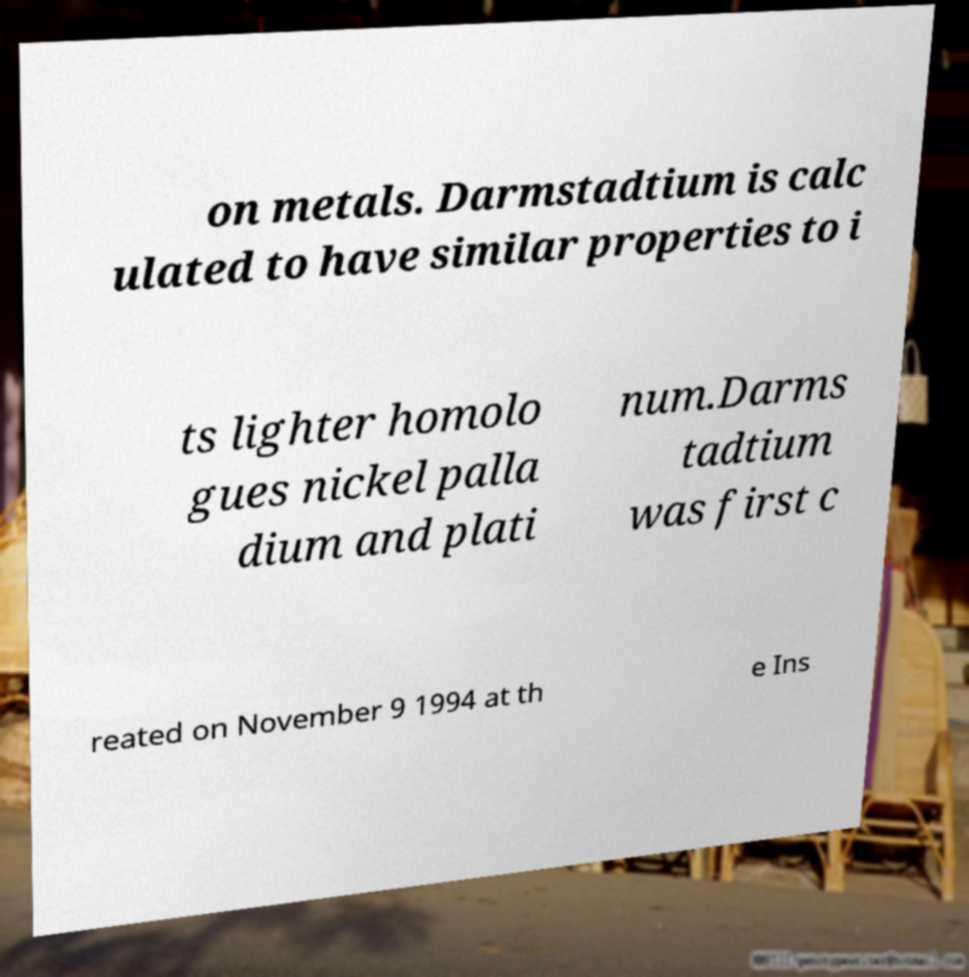I need the written content from this picture converted into text. Can you do that? on metals. Darmstadtium is calc ulated to have similar properties to i ts lighter homolo gues nickel palla dium and plati num.Darms tadtium was first c reated on November 9 1994 at th e Ins 